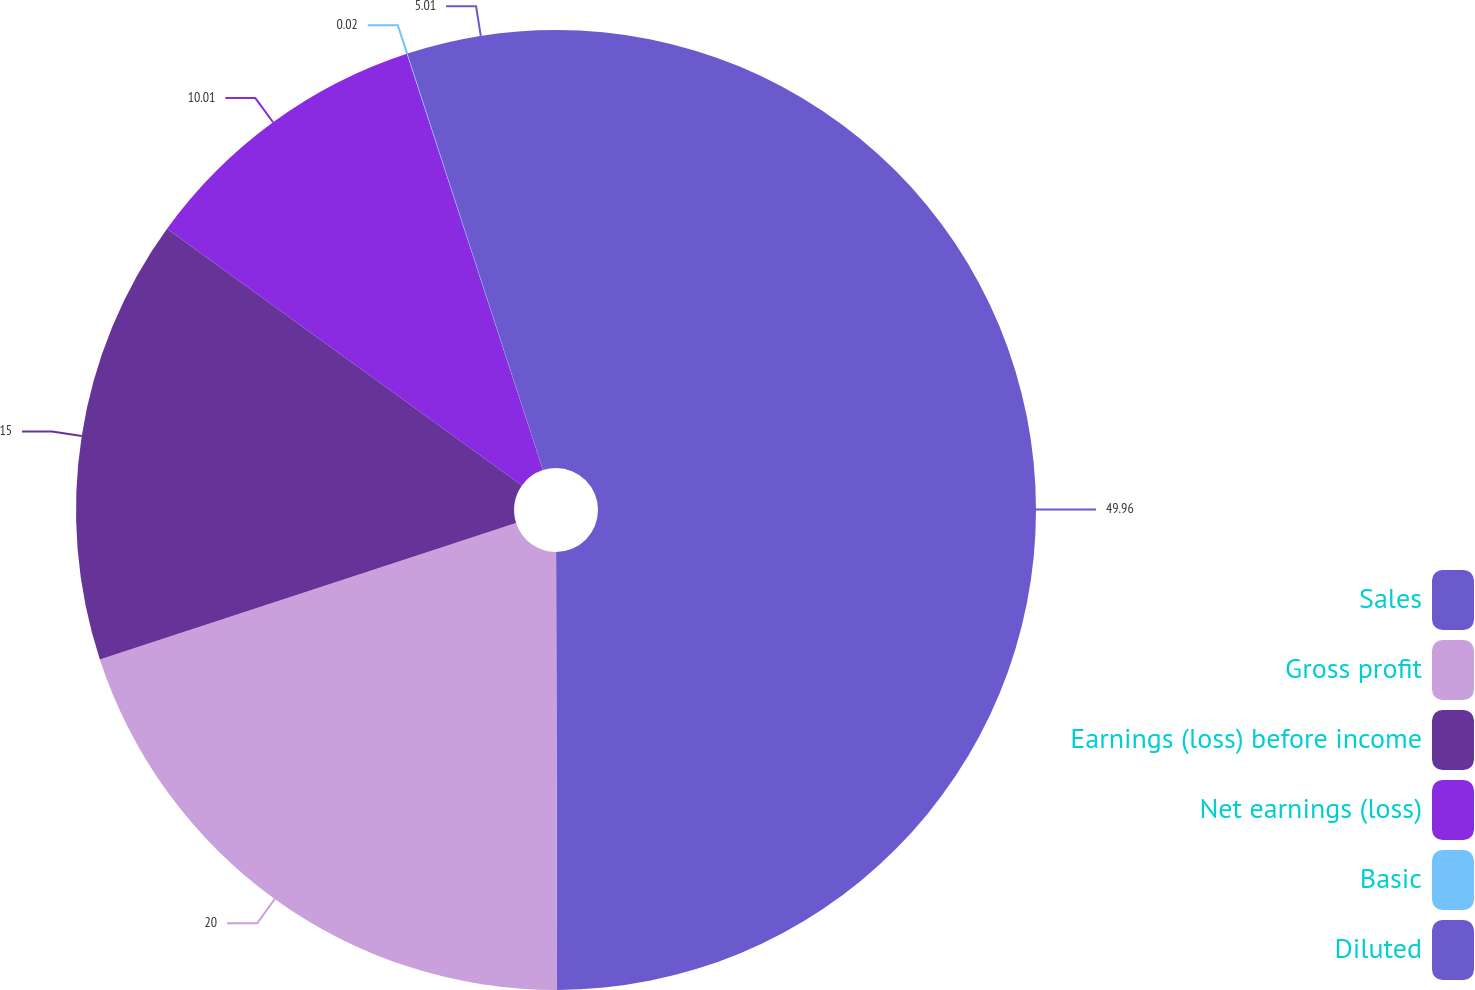<chart> <loc_0><loc_0><loc_500><loc_500><pie_chart><fcel>Sales<fcel>Gross profit<fcel>Earnings (loss) before income<fcel>Net earnings (loss)<fcel>Basic<fcel>Diluted<nl><fcel>49.97%<fcel>20.0%<fcel>15.0%<fcel>10.01%<fcel>0.02%<fcel>5.01%<nl></chart> 